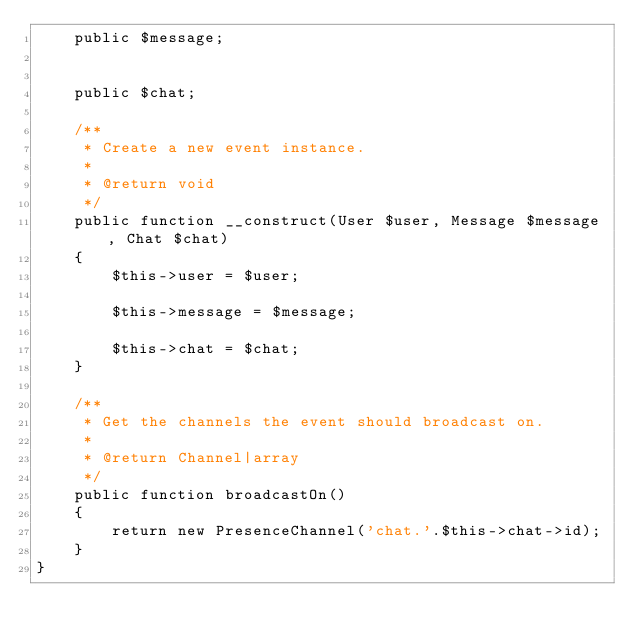<code> <loc_0><loc_0><loc_500><loc_500><_PHP_>    public $message;


    public $chat;

    /**
     * Create a new event instance.
     *
     * @return void
     */
    public function __construct(User $user, Message $message, Chat $chat)
    {
        $this->user = $user;

        $this->message = $message;

        $this->chat = $chat;
    }

    /**
     * Get the channels the event should broadcast on.
     *
     * @return Channel|array
     */
    public function broadcastOn()
    {
        return new PresenceChannel('chat.'.$this->chat->id);
    }
}
</code> 